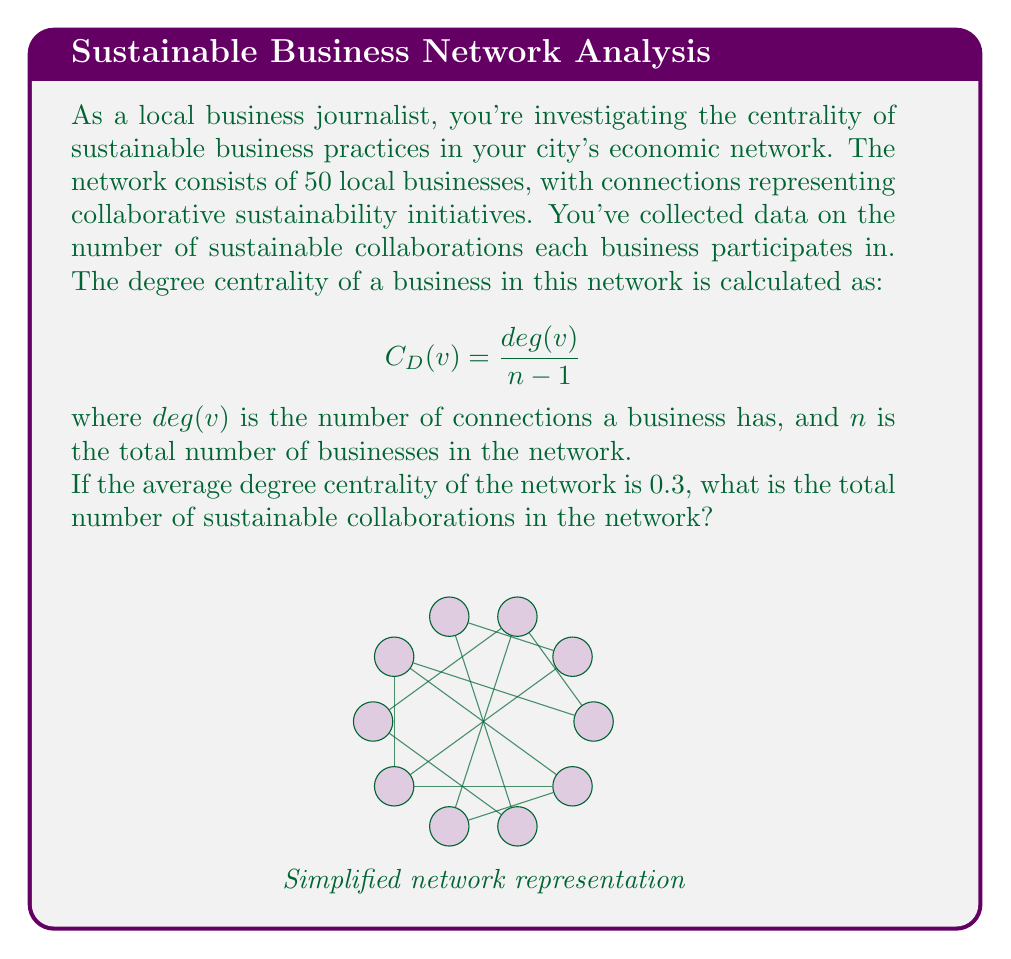Teach me how to tackle this problem. Let's approach this step-by-step:

1) First, recall the formula for degree centrality:
   $$C_D(v) = \frac{deg(v)}{n-1}$$

2) We're given that the average degree centrality is 0.3. This means:
   $$\frac{\sum_{v \in V} C_D(v)}{n} = 0.3$$

3) Substituting the degree centrality formula:
   $$\frac{\sum_{v \in V} \frac{deg(v)}{n-1}}{n} = 0.3$$

4) Simplify:
   $$\frac{\sum_{v \in V} deg(v)}{n(n-1)} = 0.3$$

5) Note that $\sum_{v \in V} deg(v)$ is equal to twice the total number of edges (collaborations) in the network, let's call this $2E$. This is because each edge contributes to the degree of two vertices.

6) So we have:
   $$\frac{2E}{n(n-1)} = 0.3$$

7) We know $n = 50$, so let's substitute:
   $$\frac{2E}{50(49)} = 0.3$$

8) Solve for $E$:
   $$2E = 0.3 * 50 * 49$$
   $$2E = 735$$
   $$E = 367.5$$

9) Since $E$ represents the number of collaborations, it must be a whole number. We round up to 368.
Answer: 368 collaborations 